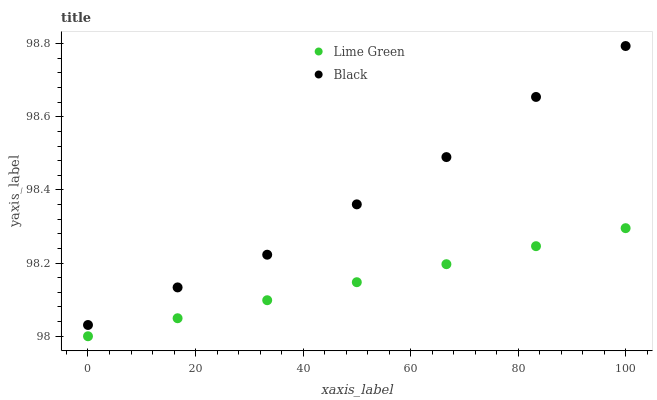Does Lime Green have the minimum area under the curve?
Answer yes or no. Yes. Does Black have the maximum area under the curve?
Answer yes or no. Yes. Does Lime Green have the maximum area under the curve?
Answer yes or no. No. Is Lime Green the smoothest?
Answer yes or no. Yes. Is Black the roughest?
Answer yes or no. Yes. Is Lime Green the roughest?
Answer yes or no. No. Does Lime Green have the lowest value?
Answer yes or no. Yes. Does Black have the highest value?
Answer yes or no. Yes. Does Lime Green have the highest value?
Answer yes or no. No. Is Lime Green less than Black?
Answer yes or no. Yes. Is Black greater than Lime Green?
Answer yes or no. Yes. Does Lime Green intersect Black?
Answer yes or no. No. 